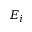<formula> <loc_0><loc_0><loc_500><loc_500>E _ { i }</formula> 